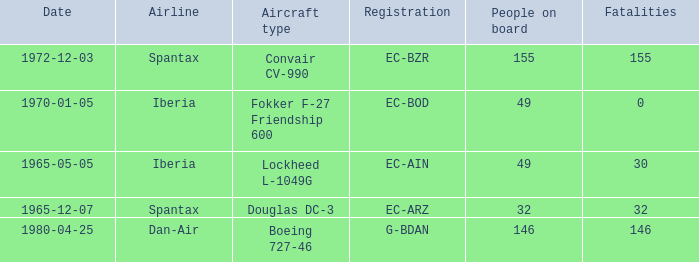How many fatalities shows for the lockheed l-1049g? 30.0. 